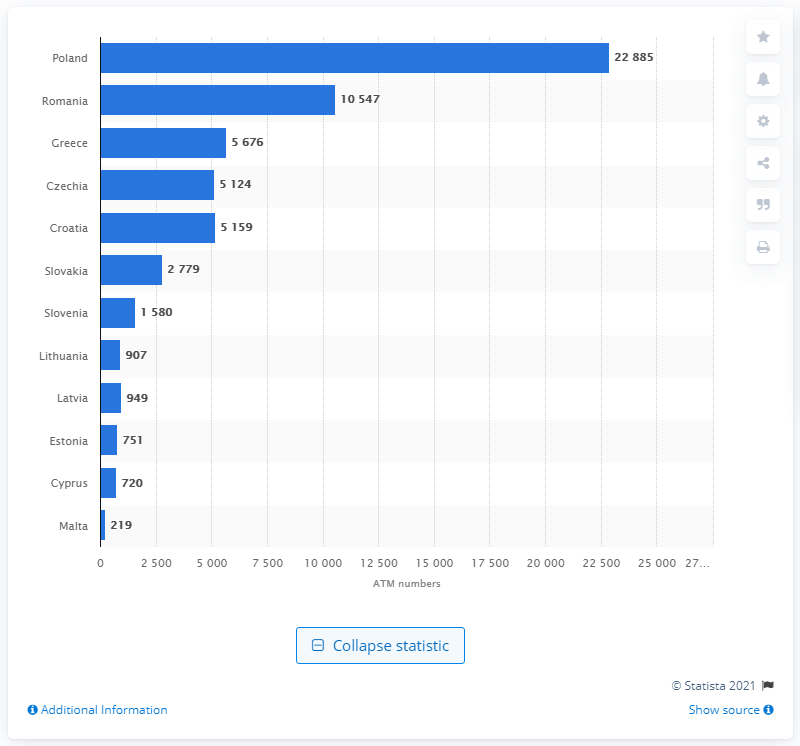Indicate a few pertinent items in this graphic. As of June 2019, a total of 22,885 ATMs were installed and operational in Poland. 